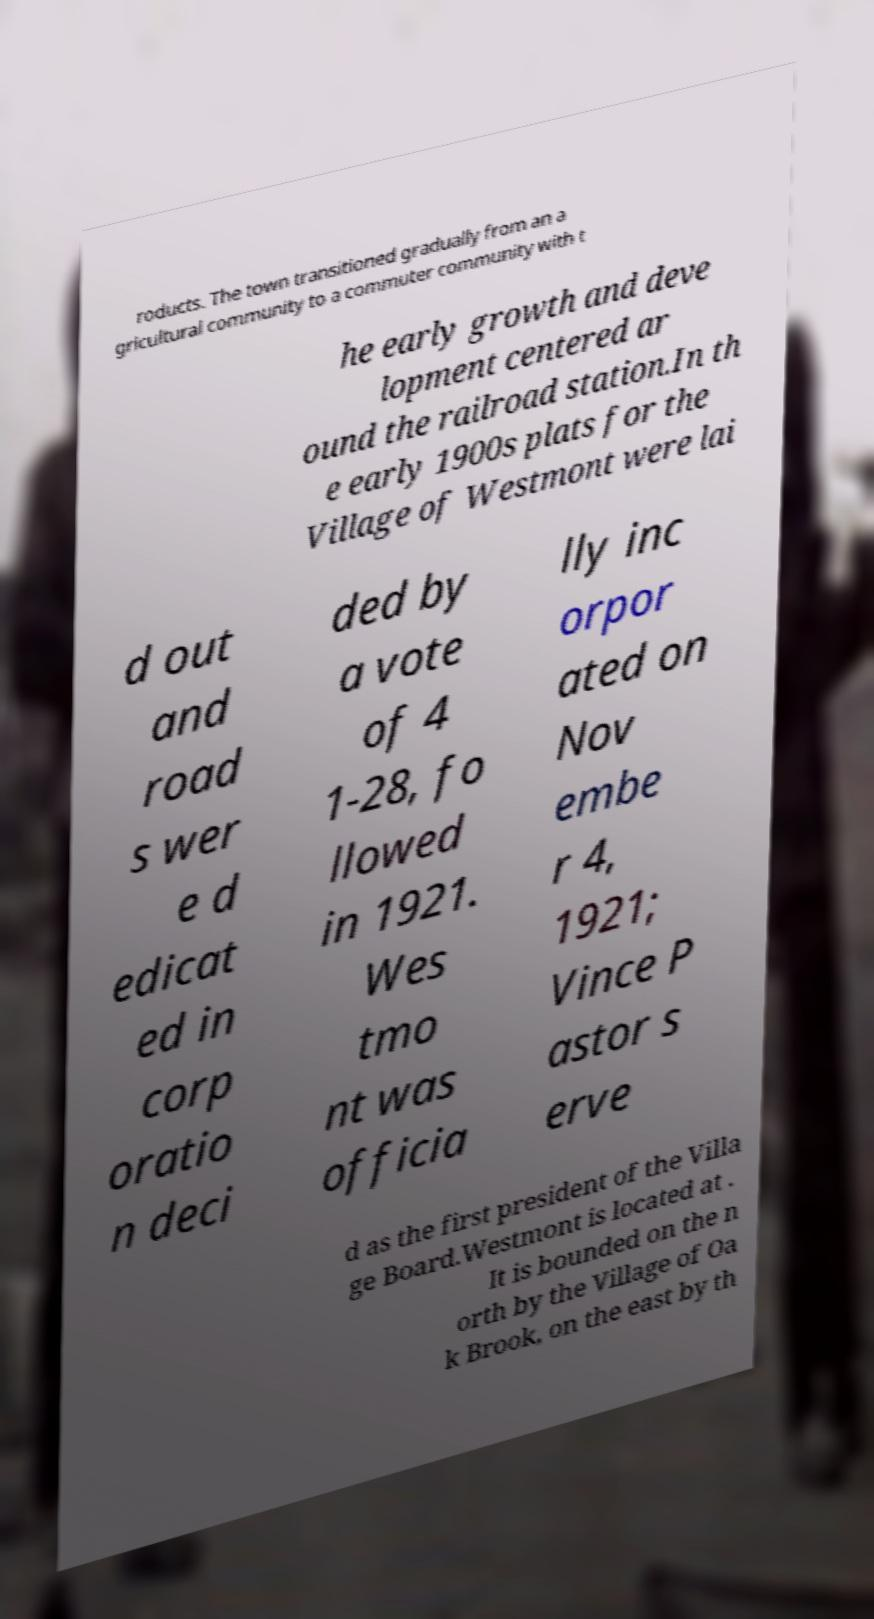There's text embedded in this image that I need extracted. Can you transcribe it verbatim? roducts. The town transitioned gradually from an a gricultural community to a commuter community with t he early growth and deve lopment centered ar ound the railroad station.In th e early 1900s plats for the Village of Westmont were lai d out and road s wer e d edicat ed in corp oratio n deci ded by a vote of 4 1-28, fo llowed in 1921. Wes tmo nt was officia lly inc orpor ated on Nov embe r 4, 1921; Vince P astor s erve d as the first president of the Villa ge Board.Westmont is located at . It is bounded on the n orth by the Village of Oa k Brook, on the east by th 